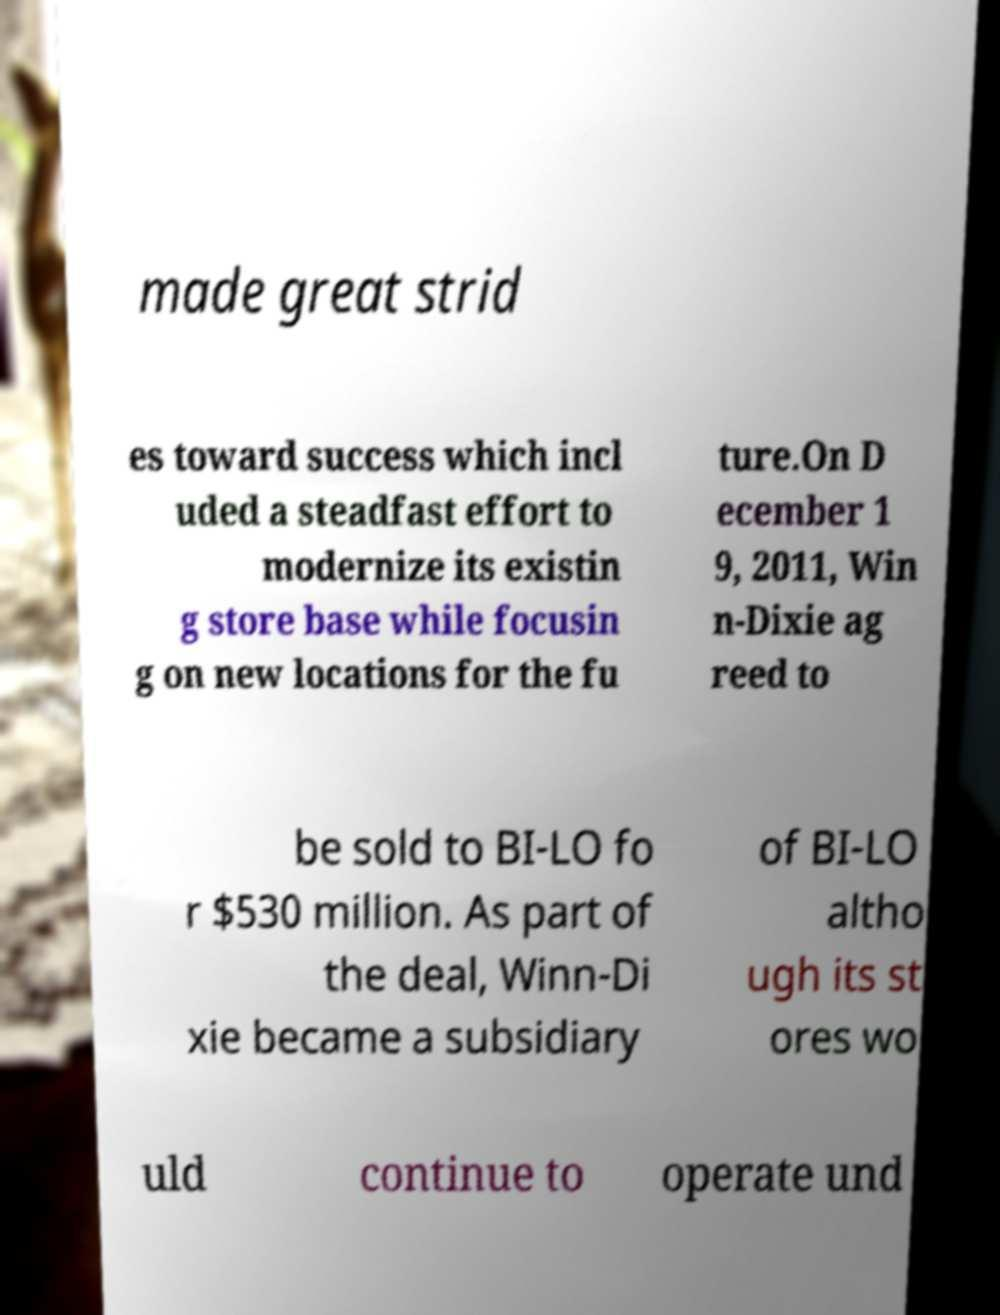Can you accurately transcribe the text from the provided image for me? made great strid es toward success which incl uded a steadfast effort to modernize its existin g store base while focusin g on new locations for the fu ture.On D ecember 1 9, 2011, Win n-Dixie ag reed to be sold to BI-LO fo r $530 million. As part of the deal, Winn-Di xie became a subsidiary of BI-LO altho ugh its st ores wo uld continue to operate und 